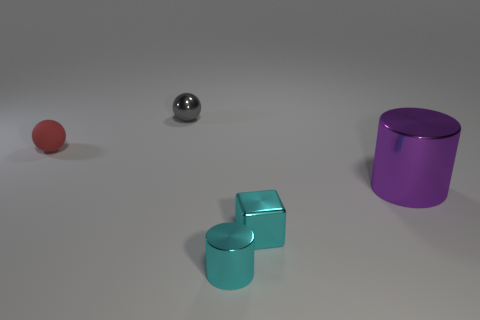What textures do the objects display? The red sphere to the left has a matte texture that diffuses light evenly, whereas the metallic sphere in the center reflects light and the surrounding environment with a high level of glossiness. The cyan cubes have a smooth, perhaps slightly reflective surface indicating a painted metal or plastic finish. Finally, the purple cylinder displays a metallic sheen, consistent with a polished metal surface. 